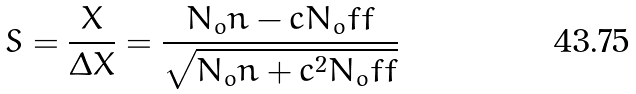Convert formula to latex. <formula><loc_0><loc_0><loc_500><loc_500>S = \frac { X } { \Delta X } = \frac { N _ { o } n - c N _ { o } f f } { \sqrt { N _ { o } n + c ^ { 2 } N _ { o } f f } }</formula> 